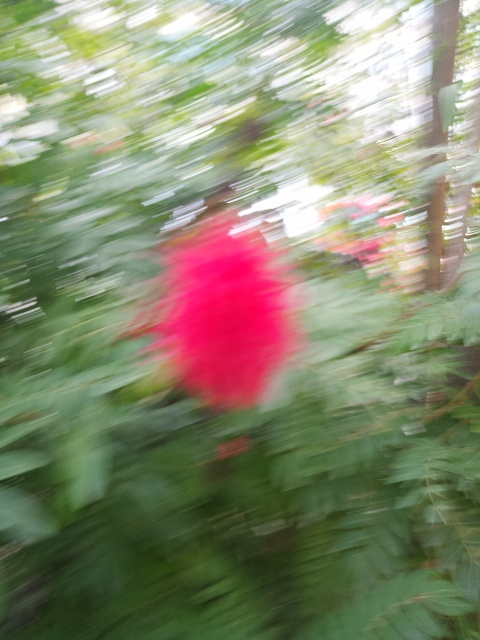Can you easily identify the objects in the image? The image provided is quite blurred, making it challenging to identify specific objects with clarity. However, the dominating blur of pink or red color in the center suggests there might be a brightly-colored flower or object of interest. The surrounding green suggests foliage or a garden-like context. Without a clearer image, however, these are just educated guesses, and concrete identification is not possible. 